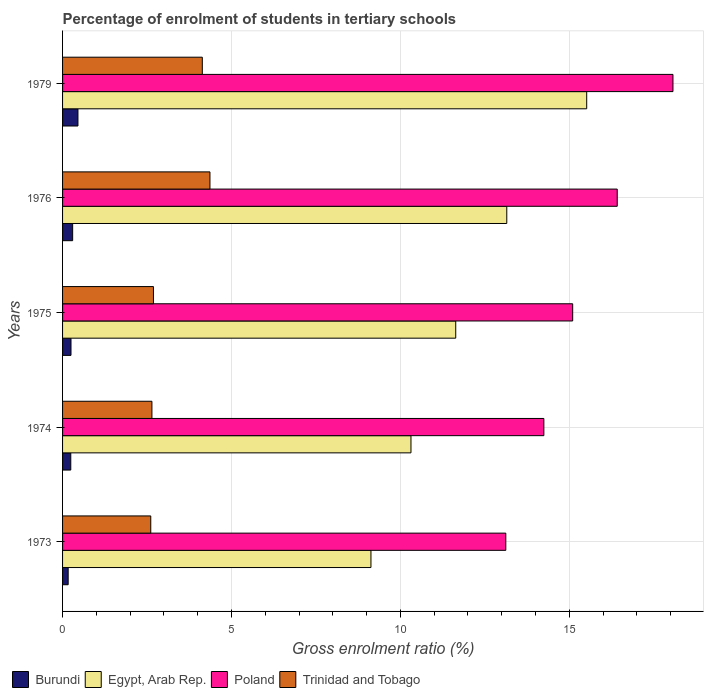How many groups of bars are there?
Offer a very short reply. 5. Are the number of bars on each tick of the Y-axis equal?
Keep it short and to the point. Yes. How many bars are there on the 1st tick from the bottom?
Offer a very short reply. 4. What is the label of the 2nd group of bars from the top?
Provide a short and direct response. 1976. In how many cases, is the number of bars for a given year not equal to the number of legend labels?
Keep it short and to the point. 0. What is the percentage of students enrolled in tertiary schools in Trinidad and Tobago in 1975?
Provide a short and direct response. 2.69. Across all years, what is the maximum percentage of students enrolled in tertiary schools in Poland?
Your answer should be compact. 18.07. Across all years, what is the minimum percentage of students enrolled in tertiary schools in Burundi?
Your response must be concise. 0.17. In which year was the percentage of students enrolled in tertiary schools in Poland maximum?
Keep it short and to the point. 1979. In which year was the percentage of students enrolled in tertiary schools in Egypt, Arab Rep. minimum?
Ensure brevity in your answer.  1973. What is the total percentage of students enrolled in tertiary schools in Egypt, Arab Rep. in the graph?
Provide a succinct answer. 59.74. What is the difference between the percentage of students enrolled in tertiary schools in Egypt, Arab Rep. in 1976 and that in 1979?
Your response must be concise. -2.37. What is the difference between the percentage of students enrolled in tertiary schools in Egypt, Arab Rep. in 1975 and the percentage of students enrolled in tertiary schools in Burundi in 1974?
Your response must be concise. 11.39. What is the average percentage of students enrolled in tertiary schools in Burundi per year?
Provide a succinct answer. 0.28. In the year 1979, what is the difference between the percentage of students enrolled in tertiary schools in Trinidad and Tobago and percentage of students enrolled in tertiary schools in Poland?
Provide a succinct answer. -13.93. In how many years, is the percentage of students enrolled in tertiary schools in Trinidad and Tobago greater than 3 %?
Offer a very short reply. 2. What is the ratio of the percentage of students enrolled in tertiary schools in Burundi in 1974 to that in 1979?
Provide a short and direct response. 0.53. Is the percentage of students enrolled in tertiary schools in Burundi in 1974 less than that in 1979?
Your answer should be compact. Yes. What is the difference between the highest and the second highest percentage of students enrolled in tertiary schools in Poland?
Offer a very short reply. 1.65. What is the difference between the highest and the lowest percentage of students enrolled in tertiary schools in Trinidad and Tobago?
Give a very brief answer. 1.75. In how many years, is the percentage of students enrolled in tertiary schools in Trinidad and Tobago greater than the average percentage of students enrolled in tertiary schools in Trinidad and Tobago taken over all years?
Make the answer very short. 2. Is it the case that in every year, the sum of the percentage of students enrolled in tertiary schools in Egypt, Arab Rep. and percentage of students enrolled in tertiary schools in Burundi is greater than the sum of percentage of students enrolled in tertiary schools in Poland and percentage of students enrolled in tertiary schools in Trinidad and Tobago?
Keep it short and to the point. No. What does the 4th bar from the top in 1979 represents?
Offer a very short reply. Burundi. What does the 2nd bar from the bottom in 1976 represents?
Your answer should be compact. Egypt, Arab Rep. How many years are there in the graph?
Your answer should be very brief. 5. How many legend labels are there?
Your response must be concise. 4. How are the legend labels stacked?
Your response must be concise. Horizontal. What is the title of the graph?
Offer a terse response. Percentage of enrolment of students in tertiary schools. What is the label or title of the Y-axis?
Make the answer very short. Years. What is the Gross enrolment ratio (%) of Burundi in 1973?
Ensure brevity in your answer.  0.17. What is the Gross enrolment ratio (%) of Egypt, Arab Rep. in 1973?
Provide a short and direct response. 9.13. What is the Gross enrolment ratio (%) in Poland in 1973?
Provide a short and direct response. 13.12. What is the Gross enrolment ratio (%) in Trinidad and Tobago in 1973?
Make the answer very short. 2.61. What is the Gross enrolment ratio (%) of Burundi in 1974?
Keep it short and to the point. 0.24. What is the Gross enrolment ratio (%) of Egypt, Arab Rep. in 1974?
Ensure brevity in your answer.  10.31. What is the Gross enrolment ratio (%) in Poland in 1974?
Offer a terse response. 14.25. What is the Gross enrolment ratio (%) of Trinidad and Tobago in 1974?
Your response must be concise. 2.64. What is the Gross enrolment ratio (%) in Burundi in 1975?
Your response must be concise. 0.25. What is the Gross enrolment ratio (%) in Egypt, Arab Rep. in 1975?
Your response must be concise. 11.64. What is the Gross enrolment ratio (%) in Poland in 1975?
Provide a short and direct response. 15.1. What is the Gross enrolment ratio (%) of Trinidad and Tobago in 1975?
Your answer should be compact. 2.69. What is the Gross enrolment ratio (%) of Burundi in 1976?
Ensure brevity in your answer.  0.3. What is the Gross enrolment ratio (%) in Egypt, Arab Rep. in 1976?
Give a very brief answer. 13.15. What is the Gross enrolment ratio (%) in Poland in 1976?
Offer a very short reply. 16.42. What is the Gross enrolment ratio (%) of Trinidad and Tobago in 1976?
Make the answer very short. 4.36. What is the Gross enrolment ratio (%) of Burundi in 1979?
Your answer should be compact. 0.46. What is the Gross enrolment ratio (%) in Egypt, Arab Rep. in 1979?
Your answer should be very brief. 15.51. What is the Gross enrolment ratio (%) in Poland in 1979?
Provide a succinct answer. 18.07. What is the Gross enrolment ratio (%) in Trinidad and Tobago in 1979?
Make the answer very short. 4.14. Across all years, what is the maximum Gross enrolment ratio (%) in Burundi?
Offer a terse response. 0.46. Across all years, what is the maximum Gross enrolment ratio (%) in Egypt, Arab Rep.?
Keep it short and to the point. 15.51. Across all years, what is the maximum Gross enrolment ratio (%) in Poland?
Offer a terse response. 18.07. Across all years, what is the maximum Gross enrolment ratio (%) of Trinidad and Tobago?
Your answer should be very brief. 4.36. Across all years, what is the minimum Gross enrolment ratio (%) in Burundi?
Offer a very short reply. 0.17. Across all years, what is the minimum Gross enrolment ratio (%) of Egypt, Arab Rep.?
Provide a short and direct response. 9.13. Across all years, what is the minimum Gross enrolment ratio (%) in Poland?
Your answer should be compact. 13.12. Across all years, what is the minimum Gross enrolment ratio (%) in Trinidad and Tobago?
Your answer should be compact. 2.61. What is the total Gross enrolment ratio (%) in Burundi in the graph?
Provide a succinct answer. 1.41. What is the total Gross enrolment ratio (%) in Egypt, Arab Rep. in the graph?
Provide a succinct answer. 59.74. What is the total Gross enrolment ratio (%) of Poland in the graph?
Provide a short and direct response. 76.95. What is the total Gross enrolment ratio (%) of Trinidad and Tobago in the graph?
Your answer should be compact. 16.44. What is the difference between the Gross enrolment ratio (%) in Burundi in 1973 and that in 1974?
Provide a succinct answer. -0.08. What is the difference between the Gross enrolment ratio (%) in Egypt, Arab Rep. in 1973 and that in 1974?
Make the answer very short. -1.18. What is the difference between the Gross enrolment ratio (%) in Poland in 1973 and that in 1974?
Provide a short and direct response. -1.13. What is the difference between the Gross enrolment ratio (%) of Trinidad and Tobago in 1973 and that in 1974?
Your response must be concise. -0.03. What is the difference between the Gross enrolment ratio (%) of Burundi in 1973 and that in 1975?
Your answer should be very brief. -0.08. What is the difference between the Gross enrolment ratio (%) of Egypt, Arab Rep. in 1973 and that in 1975?
Provide a short and direct response. -2.51. What is the difference between the Gross enrolment ratio (%) of Poland in 1973 and that in 1975?
Your response must be concise. -1.98. What is the difference between the Gross enrolment ratio (%) in Trinidad and Tobago in 1973 and that in 1975?
Your answer should be very brief. -0.08. What is the difference between the Gross enrolment ratio (%) in Burundi in 1973 and that in 1976?
Offer a terse response. -0.13. What is the difference between the Gross enrolment ratio (%) of Egypt, Arab Rep. in 1973 and that in 1976?
Offer a terse response. -4.02. What is the difference between the Gross enrolment ratio (%) in Poland in 1973 and that in 1976?
Give a very brief answer. -3.3. What is the difference between the Gross enrolment ratio (%) in Trinidad and Tobago in 1973 and that in 1976?
Give a very brief answer. -1.75. What is the difference between the Gross enrolment ratio (%) of Burundi in 1973 and that in 1979?
Offer a very short reply. -0.29. What is the difference between the Gross enrolment ratio (%) of Egypt, Arab Rep. in 1973 and that in 1979?
Your answer should be very brief. -6.39. What is the difference between the Gross enrolment ratio (%) in Poland in 1973 and that in 1979?
Ensure brevity in your answer.  -4.95. What is the difference between the Gross enrolment ratio (%) of Trinidad and Tobago in 1973 and that in 1979?
Make the answer very short. -1.53. What is the difference between the Gross enrolment ratio (%) in Burundi in 1974 and that in 1975?
Ensure brevity in your answer.  -0.01. What is the difference between the Gross enrolment ratio (%) of Egypt, Arab Rep. in 1974 and that in 1975?
Give a very brief answer. -1.33. What is the difference between the Gross enrolment ratio (%) in Poland in 1974 and that in 1975?
Ensure brevity in your answer.  -0.85. What is the difference between the Gross enrolment ratio (%) of Trinidad and Tobago in 1974 and that in 1975?
Provide a succinct answer. -0.05. What is the difference between the Gross enrolment ratio (%) of Burundi in 1974 and that in 1976?
Your response must be concise. -0.06. What is the difference between the Gross enrolment ratio (%) in Egypt, Arab Rep. in 1974 and that in 1976?
Keep it short and to the point. -2.84. What is the difference between the Gross enrolment ratio (%) of Poland in 1974 and that in 1976?
Keep it short and to the point. -2.17. What is the difference between the Gross enrolment ratio (%) in Trinidad and Tobago in 1974 and that in 1976?
Your answer should be very brief. -1.72. What is the difference between the Gross enrolment ratio (%) in Burundi in 1974 and that in 1979?
Offer a terse response. -0.21. What is the difference between the Gross enrolment ratio (%) of Egypt, Arab Rep. in 1974 and that in 1979?
Offer a terse response. -5.2. What is the difference between the Gross enrolment ratio (%) in Poland in 1974 and that in 1979?
Your answer should be very brief. -3.82. What is the difference between the Gross enrolment ratio (%) in Trinidad and Tobago in 1974 and that in 1979?
Your response must be concise. -1.49. What is the difference between the Gross enrolment ratio (%) of Burundi in 1975 and that in 1976?
Ensure brevity in your answer.  -0.05. What is the difference between the Gross enrolment ratio (%) in Egypt, Arab Rep. in 1975 and that in 1976?
Give a very brief answer. -1.51. What is the difference between the Gross enrolment ratio (%) of Poland in 1975 and that in 1976?
Keep it short and to the point. -1.32. What is the difference between the Gross enrolment ratio (%) in Trinidad and Tobago in 1975 and that in 1976?
Make the answer very short. -1.67. What is the difference between the Gross enrolment ratio (%) of Burundi in 1975 and that in 1979?
Give a very brief answer. -0.21. What is the difference between the Gross enrolment ratio (%) of Egypt, Arab Rep. in 1975 and that in 1979?
Your answer should be compact. -3.88. What is the difference between the Gross enrolment ratio (%) in Poland in 1975 and that in 1979?
Keep it short and to the point. -2.97. What is the difference between the Gross enrolment ratio (%) in Trinidad and Tobago in 1975 and that in 1979?
Your answer should be very brief. -1.45. What is the difference between the Gross enrolment ratio (%) of Burundi in 1976 and that in 1979?
Keep it short and to the point. -0.16. What is the difference between the Gross enrolment ratio (%) of Egypt, Arab Rep. in 1976 and that in 1979?
Your answer should be compact. -2.37. What is the difference between the Gross enrolment ratio (%) in Poland in 1976 and that in 1979?
Provide a succinct answer. -1.65. What is the difference between the Gross enrolment ratio (%) of Trinidad and Tobago in 1976 and that in 1979?
Your answer should be compact. 0.23. What is the difference between the Gross enrolment ratio (%) in Burundi in 1973 and the Gross enrolment ratio (%) in Egypt, Arab Rep. in 1974?
Ensure brevity in your answer.  -10.15. What is the difference between the Gross enrolment ratio (%) of Burundi in 1973 and the Gross enrolment ratio (%) of Poland in 1974?
Your answer should be very brief. -14.08. What is the difference between the Gross enrolment ratio (%) in Burundi in 1973 and the Gross enrolment ratio (%) in Trinidad and Tobago in 1974?
Provide a succinct answer. -2.48. What is the difference between the Gross enrolment ratio (%) in Egypt, Arab Rep. in 1973 and the Gross enrolment ratio (%) in Poland in 1974?
Provide a short and direct response. -5.12. What is the difference between the Gross enrolment ratio (%) of Egypt, Arab Rep. in 1973 and the Gross enrolment ratio (%) of Trinidad and Tobago in 1974?
Your answer should be very brief. 6.48. What is the difference between the Gross enrolment ratio (%) of Poland in 1973 and the Gross enrolment ratio (%) of Trinidad and Tobago in 1974?
Provide a short and direct response. 10.47. What is the difference between the Gross enrolment ratio (%) in Burundi in 1973 and the Gross enrolment ratio (%) in Egypt, Arab Rep. in 1975?
Give a very brief answer. -11.47. What is the difference between the Gross enrolment ratio (%) in Burundi in 1973 and the Gross enrolment ratio (%) in Poland in 1975?
Your answer should be very brief. -14.93. What is the difference between the Gross enrolment ratio (%) of Burundi in 1973 and the Gross enrolment ratio (%) of Trinidad and Tobago in 1975?
Offer a terse response. -2.52. What is the difference between the Gross enrolment ratio (%) in Egypt, Arab Rep. in 1973 and the Gross enrolment ratio (%) in Poland in 1975?
Give a very brief answer. -5.97. What is the difference between the Gross enrolment ratio (%) of Egypt, Arab Rep. in 1973 and the Gross enrolment ratio (%) of Trinidad and Tobago in 1975?
Your response must be concise. 6.44. What is the difference between the Gross enrolment ratio (%) of Poland in 1973 and the Gross enrolment ratio (%) of Trinidad and Tobago in 1975?
Make the answer very short. 10.43. What is the difference between the Gross enrolment ratio (%) in Burundi in 1973 and the Gross enrolment ratio (%) in Egypt, Arab Rep. in 1976?
Keep it short and to the point. -12.98. What is the difference between the Gross enrolment ratio (%) of Burundi in 1973 and the Gross enrolment ratio (%) of Poland in 1976?
Ensure brevity in your answer.  -16.25. What is the difference between the Gross enrolment ratio (%) of Burundi in 1973 and the Gross enrolment ratio (%) of Trinidad and Tobago in 1976?
Provide a succinct answer. -4.2. What is the difference between the Gross enrolment ratio (%) of Egypt, Arab Rep. in 1973 and the Gross enrolment ratio (%) of Poland in 1976?
Give a very brief answer. -7.29. What is the difference between the Gross enrolment ratio (%) in Egypt, Arab Rep. in 1973 and the Gross enrolment ratio (%) in Trinidad and Tobago in 1976?
Offer a terse response. 4.77. What is the difference between the Gross enrolment ratio (%) of Poland in 1973 and the Gross enrolment ratio (%) of Trinidad and Tobago in 1976?
Provide a short and direct response. 8.76. What is the difference between the Gross enrolment ratio (%) in Burundi in 1973 and the Gross enrolment ratio (%) in Egypt, Arab Rep. in 1979?
Offer a very short reply. -15.35. What is the difference between the Gross enrolment ratio (%) in Burundi in 1973 and the Gross enrolment ratio (%) in Poland in 1979?
Make the answer very short. -17.9. What is the difference between the Gross enrolment ratio (%) in Burundi in 1973 and the Gross enrolment ratio (%) in Trinidad and Tobago in 1979?
Ensure brevity in your answer.  -3.97. What is the difference between the Gross enrolment ratio (%) of Egypt, Arab Rep. in 1973 and the Gross enrolment ratio (%) of Poland in 1979?
Your response must be concise. -8.94. What is the difference between the Gross enrolment ratio (%) in Egypt, Arab Rep. in 1973 and the Gross enrolment ratio (%) in Trinidad and Tobago in 1979?
Provide a succinct answer. 4.99. What is the difference between the Gross enrolment ratio (%) in Poland in 1973 and the Gross enrolment ratio (%) in Trinidad and Tobago in 1979?
Your answer should be very brief. 8.98. What is the difference between the Gross enrolment ratio (%) of Burundi in 1974 and the Gross enrolment ratio (%) of Egypt, Arab Rep. in 1975?
Provide a succinct answer. -11.39. What is the difference between the Gross enrolment ratio (%) of Burundi in 1974 and the Gross enrolment ratio (%) of Poland in 1975?
Make the answer very short. -14.86. What is the difference between the Gross enrolment ratio (%) in Burundi in 1974 and the Gross enrolment ratio (%) in Trinidad and Tobago in 1975?
Your answer should be compact. -2.45. What is the difference between the Gross enrolment ratio (%) in Egypt, Arab Rep. in 1974 and the Gross enrolment ratio (%) in Poland in 1975?
Your answer should be compact. -4.79. What is the difference between the Gross enrolment ratio (%) of Egypt, Arab Rep. in 1974 and the Gross enrolment ratio (%) of Trinidad and Tobago in 1975?
Make the answer very short. 7.62. What is the difference between the Gross enrolment ratio (%) in Poland in 1974 and the Gross enrolment ratio (%) in Trinidad and Tobago in 1975?
Ensure brevity in your answer.  11.56. What is the difference between the Gross enrolment ratio (%) in Burundi in 1974 and the Gross enrolment ratio (%) in Egypt, Arab Rep. in 1976?
Give a very brief answer. -12.9. What is the difference between the Gross enrolment ratio (%) of Burundi in 1974 and the Gross enrolment ratio (%) of Poland in 1976?
Make the answer very short. -16.17. What is the difference between the Gross enrolment ratio (%) of Burundi in 1974 and the Gross enrolment ratio (%) of Trinidad and Tobago in 1976?
Offer a terse response. -4.12. What is the difference between the Gross enrolment ratio (%) in Egypt, Arab Rep. in 1974 and the Gross enrolment ratio (%) in Poland in 1976?
Offer a terse response. -6.11. What is the difference between the Gross enrolment ratio (%) of Egypt, Arab Rep. in 1974 and the Gross enrolment ratio (%) of Trinidad and Tobago in 1976?
Ensure brevity in your answer.  5.95. What is the difference between the Gross enrolment ratio (%) of Poland in 1974 and the Gross enrolment ratio (%) of Trinidad and Tobago in 1976?
Provide a short and direct response. 9.88. What is the difference between the Gross enrolment ratio (%) in Burundi in 1974 and the Gross enrolment ratio (%) in Egypt, Arab Rep. in 1979?
Your answer should be compact. -15.27. What is the difference between the Gross enrolment ratio (%) in Burundi in 1974 and the Gross enrolment ratio (%) in Poland in 1979?
Your response must be concise. -17.82. What is the difference between the Gross enrolment ratio (%) of Burundi in 1974 and the Gross enrolment ratio (%) of Trinidad and Tobago in 1979?
Provide a succinct answer. -3.89. What is the difference between the Gross enrolment ratio (%) in Egypt, Arab Rep. in 1974 and the Gross enrolment ratio (%) in Poland in 1979?
Offer a terse response. -7.76. What is the difference between the Gross enrolment ratio (%) of Egypt, Arab Rep. in 1974 and the Gross enrolment ratio (%) of Trinidad and Tobago in 1979?
Your answer should be very brief. 6.18. What is the difference between the Gross enrolment ratio (%) in Poland in 1974 and the Gross enrolment ratio (%) in Trinidad and Tobago in 1979?
Provide a short and direct response. 10.11. What is the difference between the Gross enrolment ratio (%) in Burundi in 1975 and the Gross enrolment ratio (%) in Egypt, Arab Rep. in 1976?
Your response must be concise. -12.9. What is the difference between the Gross enrolment ratio (%) in Burundi in 1975 and the Gross enrolment ratio (%) in Poland in 1976?
Your answer should be compact. -16.17. What is the difference between the Gross enrolment ratio (%) of Burundi in 1975 and the Gross enrolment ratio (%) of Trinidad and Tobago in 1976?
Give a very brief answer. -4.11. What is the difference between the Gross enrolment ratio (%) in Egypt, Arab Rep. in 1975 and the Gross enrolment ratio (%) in Poland in 1976?
Keep it short and to the point. -4.78. What is the difference between the Gross enrolment ratio (%) of Egypt, Arab Rep. in 1975 and the Gross enrolment ratio (%) of Trinidad and Tobago in 1976?
Your answer should be very brief. 7.27. What is the difference between the Gross enrolment ratio (%) of Poland in 1975 and the Gross enrolment ratio (%) of Trinidad and Tobago in 1976?
Provide a short and direct response. 10.74. What is the difference between the Gross enrolment ratio (%) in Burundi in 1975 and the Gross enrolment ratio (%) in Egypt, Arab Rep. in 1979?
Keep it short and to the point. -15.26. What is the difference between the Gross enrolment ratio (%) in Burundi in 1975 and the Gross enrolment ratio (%) in Poland in 1979?
Make the answer very short. -17.82. What is the difference between the Gross enrolment ratio (%) of Burundi in 1975 and the Gross enrolment ratio (%) of Trinidad and Tobago in 1979?
Give a very brief answer. -3.89. What is the difference between the Gross enrolment ratio (%) of Egypt, Arab Rep. in 1975 and the Gross enrolment ratio (%) of Poland in 1979?
Provide a short and direct response. -6.43. What is the difference between the Gross enrolment ratio (%) of Egypt, Arab Rep. in 1975 and the Gross enrolment ratio (%) of Trinidad and Tobago in 1979?
Ensure brevity in your answer.  7.5. What is the difference between the Gross enrolment ratio (%) of Poland in 1975 and the Gross enrolment ratio (%) of Trinidad and Tobago in 1979?
Make the answer very short. 10.96. What is the difference between the Gross enrolment ratio (%) in Burundi in 1976 and the Gross enrolment ratio (%) in Egypt, Arab Rep. in 1979?
Provide a succinct answer. -15.22. What is the difference between the Gross enrolment ratio (%) in Burundi in 1976 and the Gross enrolment ratio (%) in Poland in 1979?
Give a very brief answer. -17.77. What is the difference between the Gross enrolment ratio (%) of Burundi in 1976 and the Gross enrolment ratio (%) of Trinidad and Tobago in 1979?
Keep it short and to the point. -3.84. What is the difference between the Gross enrolment ratio (%) in Egypt, Arab Rep. in 1976 and the Gross enrolment ratio (%) in Poland in 1979?
Provide a succinct answer. -4.92. What is the difference between the Gross enrolment ratio (%) in Egypt, Arab Rep. in 1976 and the Gross enrolment ratio (%) in Trinidad and Tobago in 1979?
Offer a very short reply. 9.01. What is the difference between the Gross enrolment ratio (%) in Poland in 1976 and the Gross enrolment ratio (%) in Trinidad and Tobago in 1979?
Offer a terse response. 12.28. What is the average Gross enrolment ratio (%) of Burundi per year?
Make the answer very short. 0.28. What is the average Gross enrolment ratio (%) of Egypt, Arab Rep. per year?
Ensure brevity in your answer.  11.95. What is the average Gross enrolment ratio (%) in Poland per year?
Your answer should be very brief. 15.39. What is the average Gross enrolment ratio (%) of Trinidad and Tobago per year?
Make the answer very short. 3.29. In the year 1973, what is the difference between the Gross enrolment ratio (%) of Burundi and Gross enrolment ratio (%) of Egypt, Arab Rep.?
Ensure brevity in your answer.  -8.96. In the year 1973, what is the difference between the Gross enrolment ratio (%) in Burundi and Gross enrolment ratio (%) in Poland?
Give a very brief answer. -12.95. In the year 1973, what is the difference between the Gross enrolment ratio (%) in Burundi and Gross enrolment ratio (%) in Trinidad and Tobago?
Your answer should be compact. -2.44. In the year 1973, what is the difference between the Gross enrolment ratio (%) in Egypt, Arab Rep. and Gross enrolment ratio (%) in Poland?
Give a very brief answer. -3.99. In the year 1973, what is the difference between the Gross enrolment ratio (%) in Egypt, Arab Rep. and Gross enrolment ratio (%) in Trinidad and Tobago?
Provide a succinct answer. 6.52. In the year 1973, what is the difference between the Gross enrolment ratio (%) in Poland and Gross enrolment ratio (%) in Trinidad and Tobago?
Offer a terse response. 10.51. In the year 1974, what is the difference between the Gross enrolment ratio (%) of Burundi and Gross enrolment ratio (%) of Egypt, Arab Rep.?
Offer a very short reply. -10.07. In the year 1974, what is the difference between the Gross enrolment ratio (%) of Burundi and Gross enrolment ratio (%) of Poland?
Offer a very short reply. -14. In the year 1974, what is the difference between the Gross enrolment ratio (%) in Burundi and Gross enrolment ratio (%) in Trinidad and Tobago?
Provide a succinct answer. -2.4. In the year 1974, what is the difference between the Gross enrolment ratio (%) of Egypt, Arab Rep. and Gross enrolment ratio (%) of Poland?
Keep it short and to the point. -3.93. In the year 1974, what is the difference between the Gross enrolment ratio (%) of Egypt, Arab Rep. and Gross enrolment ratio (%) of Trinidad and Tobago?
Your answer should be compact. 7.67. In the year 1974, what is the difference between the Gross enrolment ratio (%) of Poland and Gross enrolment ratio (%) of Trinidad and Tobago?
Your answer should be compact. 11.6. In the year 1975, what is the difference between the Gross enrolment ratio (%) in Burundi and Gross enrolment ratio (%) in Egypt, Arab Rep.?
Your answer should be compact. -11.39. In the year 1975, what is the difference between the Gross enrolment ratio (%) of Burundi and Gross enrolment ratio (%) of Poland?
Your answer should be very brief. -14.85. In the year 1975, what is the difference between the Gross enrolment ratio (%) in Burundi and Gross enrolment ratio (%) in Trinidad and Tobago?
Provide a succinct answer. -2.44. In the year 1975, what is the difference between the Gross enrolment ratio (%) in Egypt, Arab Rep. and Gross enrolment ratio (%) in Poland?
Provide a short and direct response. -3.46. In the year 1975, what is the difference between the Gross enrolment ratio (%) in Egypt, Arab Rep. and Gross enrolment ratio (%) in Trinidad and Tobago?
Offer a very short reply. 8.95. In the year 1975, what is the difference between the Gross enrolment ratio (%) of Poland and Gross enrolment ratio (%) of Trinidad and Tobago?
Ensure brevity in your answer.  12.41. In the year 1976, what is the difference between the Gross enrolment ratio (%) in Burundi and Gross enrolment ratio (%) in Egypt, Arab Rep.?
Give a very brief answer. -12.85. In the year 1976, what is the difference between the Gross enrolment ratio (%) in Burundi and Gross enrolment ratio (%) in Poland?
Your answer should be compact. -16.12. In the year 1976, what is the difference between the Gross enrolment ratio (%) in Burundi and Gross enrolment ratio (%) in Trinidad and Tobago?
Keep it short and to the point. -4.06. In the year 1976, what is the difference between the Gross enrolment ratio (%) of Egypt, Arab Rep. and Gross enrolment ratio (%) of Poland?
Make the answer very short. -3.27. In the year 1976, what is the difference between the Gross enrolment ratio (%) in Egypt, Arab Rep. and Gross enrolment ratio (%) in Trinidad and Tobago?
Give a very brief answer. 8.79. In the year 1976, what is the difference between the Gross enrolment ratio (%) of Poland and Gross enrolment ratio (%) of Trinidad and Tobago?
Provide a short and direct response. 12.06. In the year 1979, what is the difference between the Gross enrolment ratio (%) in Burundi and Gross enrolment ratio (%) in Egypt, Arab Rep.?
Your answer should be very brief. -15.06. In the year 1979, what is the difference between the Gross enrolment ratio (%) of Burundi and Gross enrolment ratio (%) of Poland?
Make the answer very short. -17.61. In the year 1979, what is the difference between the Gross enrolment ratio (%) in Burundi and Gross enrolment ratio (%) in Trinidad and Tobago?
Make the answer very short. -3.68. In the year 1979, what is the difference between the Gross enrolment ratio (%) in Egypt, Arab Rep. and Gross enrolment ratio (%) in Poland?
Provide a succinct answer. -2.55. In the year 1979, what is the difference between the Gross enrolment ratio (%) in Egypt, Arab Rep. and Gross enrolment ratio (%) in Trinidad and Tobago?
Provide a short and direct response. 11.38. In the year 1979, what is the difference between the Gross enrolment ratio (%) in Poland and Gross enrolment ratio (%) in Trinidad and Tobago?
Make the answer very short. 13.93. What is the ratio of the Gross enrolment ratio (%) of Burundi in 1973 to that in 1974?
Offer a very short reply. 0.68. What is the ratio of the Gross enrolment ratio (%) of Egypt, Arab Rep. in 1973 to that in 1974?
Keep it short and to the point. 0.89. What is the ratio of the Gross enrolment ratio (%) in Poland in 1973 to that in 1974?
Make the answer very short. 0.92. What is the ratio of the Gross enrolment ratio (%) in Trinidad and Tobago in 1973 to that in 1974?
Keep it short and to the point. 0.99. What is the ratio of the Gross enrolment ratio (%) in Burundi in 1973 to that in 1975?
Provide a succinct answer. 0.66. What is the ratio of the Gross enrolment ratio (%) of Egypt, Arab Rep. in 1973 to that in 1975?
Offer a terse response. 0.78. What is the ratio of the Gross enrolment ratio (%) of Poland in 1973 to that in 1975?
Provide a short and direct response. 0.87. What is the ratio of the Gross enrolment ratio (%) of Trinidad and Tobago in 1973 to that in 1975?
Offer a very short reply. 0.97. What is the ratio of the Gross enrolment ratio (%) of Burundi in 1973 to that in 1976?
Ensure brevity in your answer.  0.56. What is the ratio of the Gross enrolment ratio (%) in Egypt, Arab Rep. in 1973 to that in 1976?
Keep it short and to the point. 0.69. What is the ratio of the Gross enrolment ratio (%) of Poland in 1973 to that in 1976?
Provide a succinct answer. 0.8. What is the ratio of the Gross enrolment ratio (%) in Trinidad and Tobago in 1973 to that in 1976?
Make the answer very short. 0.6. What is the ratio of the Gross enrolment ratio (%) in Burundi in 1973 to that in 1979?
Give a very brief answer. 0.36. What is the ratio of the Gross enrolment ratio (%) in Egypt, Arab Rep. in 1973 to that in 1979?
Your response must be concise. 0.59. What is the ratio of the Gross enrolment ratio (%) in Poland in 1973 to that in 1979?
Keep it short and to the point. 0.73. What is the ratio of the Gross enrolment ratio (%) in Trinidad and Tobago in 1973 to that in 1979?
Ensure brevity in your answer.  0.63. What is the ratio of the Gross enrolment ratio (%) in Burundi in 1974 to that in 1975?
Give a very brief answer. 0.97. What is the ratio of the Gross enrolment ratio (%) of Egypt, Arab Rep. in 1974 to that in 1975?
Your response must be concise. 0.89. What is the ratio of the Gross enrolment ratio (%) in Poland in 1974 to that in 1975?
Offer a very short reply. 0.94. What is the ratio of the Gross enrolment ratio (%) in Burundi in 1974 to that in 1976?
Your answer should be very brief. 0.82. What is the ratio of the Gross enrolment ratio (%) in Egypt, Arab Rep. in 1974 to that in 1976?
Ensure brevity in your answer.  0.78. What is the ratio of the Gross enrolment ratio (%) in Poland in 1974 to that in 1976?
Your answer should be very brief. 0.87. What is the ratio of the Gross enrolment ratio (%) of Trinidad and Tobago in 1974 to that in 1976?
Offer a very short reply. 0.61. What is the ratio of the Gross enrolment ratio (%) in Burundi in 1974 to that in 1979?
Provide a succinct answer. 0.53. What is the ratio of the Gross enrolment ratio (%) of Egypt, Arab Rep. in 1974 to that in 1979?
Provide a succinct answer. 0.66. What is the ratio of the Gross enrolment ratio (%) of Poland in 1974 to that in 1979?
Offer a terse response. 0.79. What is the ratio of the Gross enrolment ratio (%) in Trinidad and Tobago in 1974 to that in 1979?
Keep it short and to the point. 0.64. What is the ratio of the Gross enrolment ratio (%) of Burundi in 1975 to that in 1976?
Offer a terse response. 0.84. What is the ratio of the Gross enrolment ratio (%) of Egypt, Arab Rep. in 1975 to that in 1976?
Make the answer very short. 0.89. What is the ratio of the Gross enrolment ratio (%) of Poland in 1975 to that in 1976?
Provide a short and direct response. 0.92. What is the ratio of the Gross enrolment ratio (%) in Trinidad and Tobago in 1975 to that in 1976?
Make the answer very short. 0.62. What is the ratio of the Gross enrolment ratio (%) in Burundi in 1975 to that in 1979?
Give a very brief answer. 0.55. What is the ratio of the Gross enrolment ratio (%) in Egypt, Arab Rep. in 1975 to that in 1979?
Your response must be concise. 0.75. What is the ratio of the Gross enrolment ratio (%) of Poland in 1975 to that in 1979?
Keep it short and to the point. 0.84. What is the ratio of the Gross enrolment ratio (%) in Trinidad and Tobago in 1975 to that in 1979?
Give a very brief answer. 0.65. What is the ratio of the Gross enrolment ratio (%) of Burundi in 1976 to that in 1979?
Your answer should be compact. 0.66. What is the ratio of the Gross enrolment ratio (%) of Egypt, Arab Rep. in 1976 to that in 1979?
Your answer should be compact. 0.85. What is the ratio of the Gross enrolment ratio (%) in Poland in 1976 to that in 1979?
Offer a very short reply. 0.91. What is the ratio of the Gross enrolment ratio (%) of Trinidad and Tobago in 1976 to that in 1979?
Make the answer very short. 1.05. What is the difference between the highest and the second highest Gross enrolment ratio (%) of Burundi?
Your response must be concise. 0.16. What is the difference between the highest and the second highest Gross enrolment ratio (%) of Egypt, Arab Rep.?
Offer a very short reply. 2.37. What is the difference between the highest and the second highest Gross enrolment ratio (%) of Poland?
Provide a short and direct response. 1.65. What is the difference between the highest and the second highest Gross enrolment ratio (%) of Trinidad and Tobago?
Offer a terse response. 0.23. What is the difference between the highest and the lowest Gross enrolment ratio (%) in Burundi?
Provide a succinct answer. 0.29. What is the difference between the highest and the lowest Gross enrolment ratio (%) in Egypt, Arab Rep.?
Make the answer very short. 6.39. What is the difference between the highest and the lowest Gross enrolment ratio (%) in Poland?
Provide a short and direct response. 4.95. What is the difference between the highest and the lowest Gross enrolment ratio (%) in Trinidad and Tobago?
Keep it short and to the point. 1.75. 